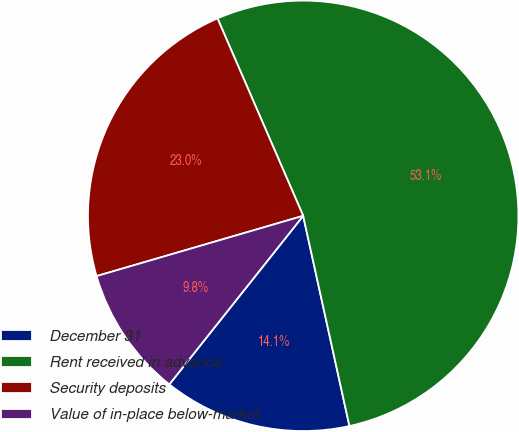<chart> <loc_0><loc_0><loc_500><loc_500><pie_chart><fcel>December 31<fcel>Rent received in advance<fcel>Security deposits<fcel>Value of in-place below-market<nl><fcel>14.13%<fcel>53.07%<fcel>23.0%<fcel>9.8%<nl></chart> 